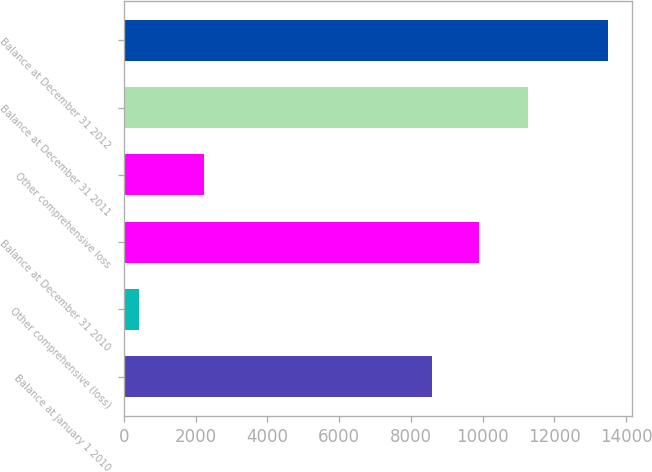Convert chart. <chart><loc_0><loc_0><loc_500><loc_500><bar_chart><fcel>Balance at January 1 2010<fcel>Other comprehensive (loss)<fcel>Balance at December 31 2010<fcel>Other comprehensive loss<fcel>Balance at December 31 2011<fcel>Balance at December 31 2012<nl><fcel>8595<fcel>415<fcel>9902.8<fcel>2247<fcel>11257<fcel>13493<nl></chart> 